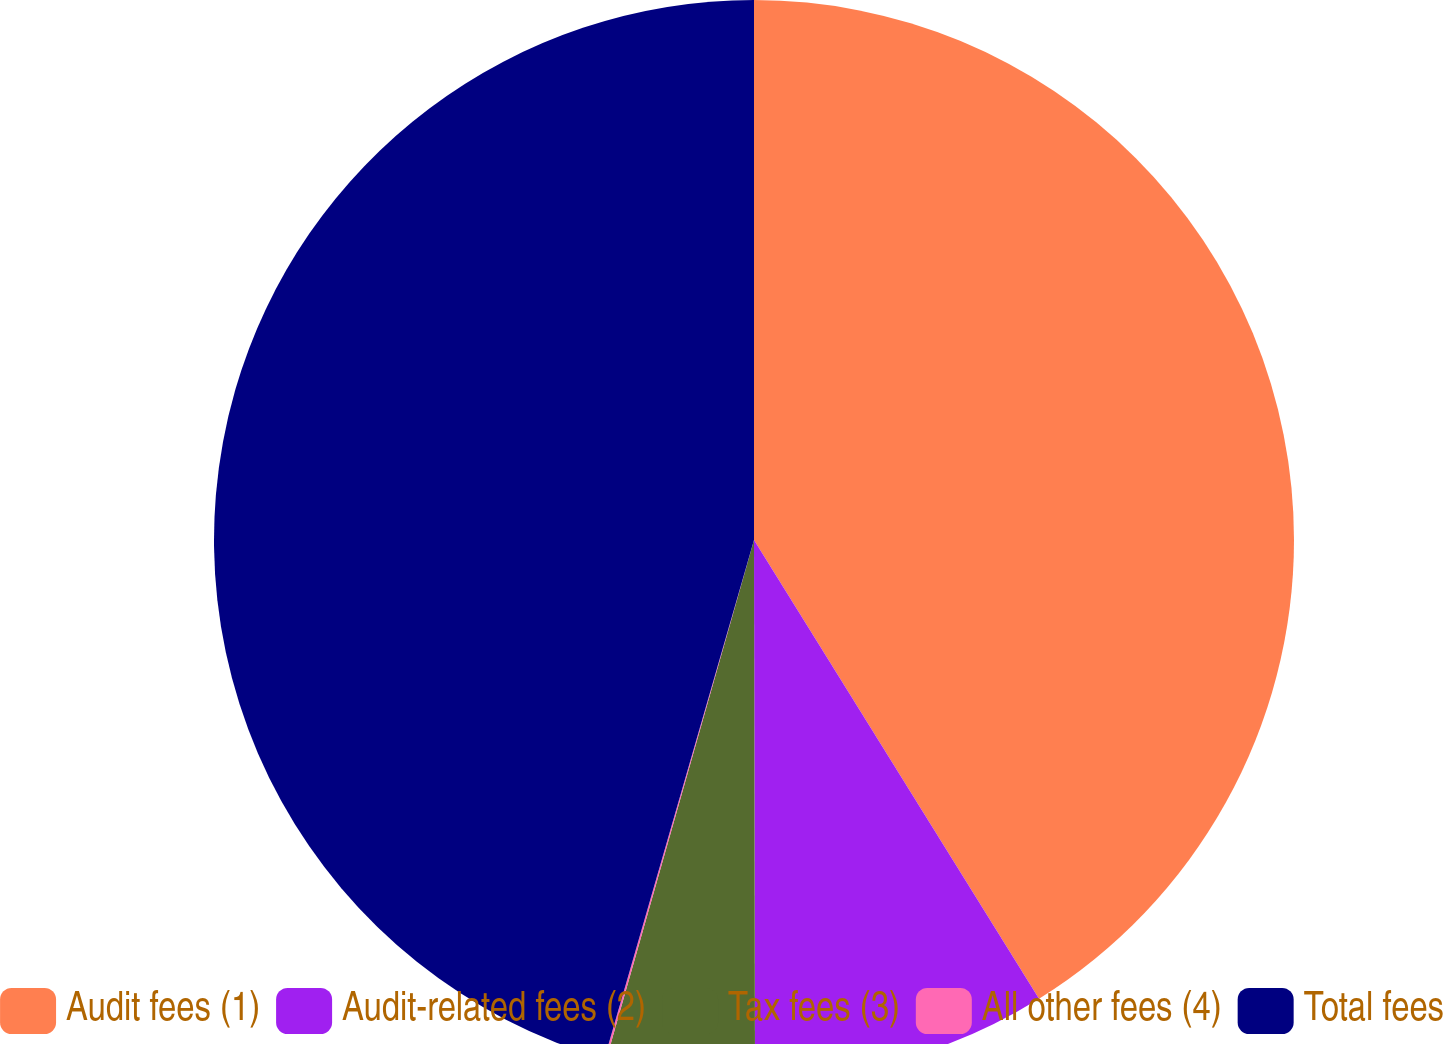Convert chart to OTSL. <chart><loc_0><loc_0><loc_500><loc_500><pie_chart><fcel>Audit fees (1)<fcel>Audit-related fees (2)<fcel>Tax fees (3)<fcel>All other fees (4)<fcel>Total fees<nl><fcel>41.15%<fcel>8.82%<fcel>4.44%<fcel>0.06%<fcel>45.53%<nl></chart> 